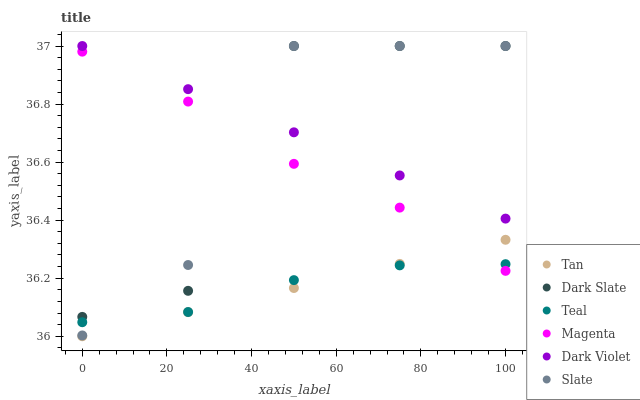Does Tan have the minimum area under the curve?
Answer yes or no. Yes. Does Dark Violet have the maximum area under the curve?
Answer yes or no. Yes. Does Dark Slate have the minimum area under the curve?
Answer yes or no. No. Does Dark Slate have the maximum area under the curve?
Answer yes or no. No. Is Dark Violet the smoothest?
Answer yes or no. Yes. Is Dark Slate the roughest?
Answer yes or no. Yes. Is Dark Slate the smoothest?
Answer yes or no. No. Is Dark Violet the roughest?
Answer yes or no. No. Does Tan have the lowest value?
Answer yes or no. Yes. Does Dark Slate have the lowest value?
Answer yes or no. No. Does Dark Slate have the highest value?
Answer yes or no. Yes. Does Teal have the highest value?
Answer yes or no. No. Is Teal less than Dark Violet?
Answer yes or no. Yes. Is Dark Violet greater than Teal?
Answer yes or no. Yes. Does Teal intersect Slate?
Answer yes or no. Yes. Is Teal less than Slate?
Answer yes or no. No. Is Teal greater than Slate?
Answer yes or no. No. Does Teal intersect Dark Violet?
Answer yes or no. No. 